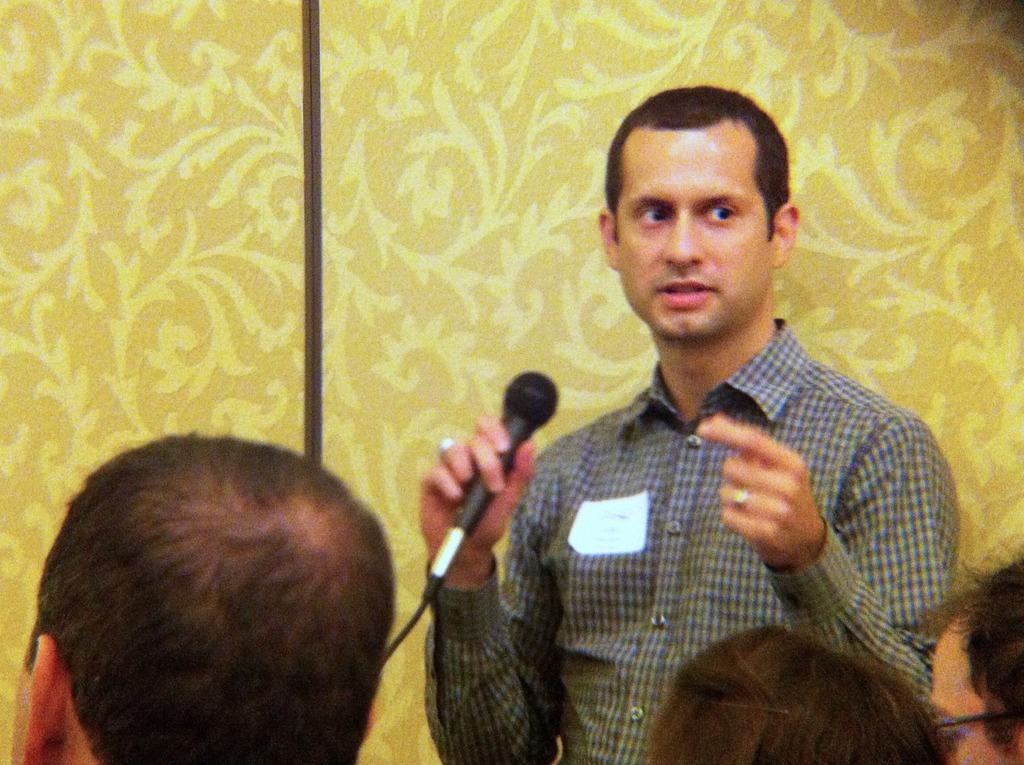Who is the main subject in the image? There is a man in the image. What is the man wearing? The man is wearing a checked shirt. What is the man holding in the image? The man is holding a mic. Can you describe the people sitting in front of the man? There are people sitting in front of the man, but their specific features are not mentioned in the facts. What color is the wall behind the man? The wall behind the man is yellow. What type of rabbit can be seen hopping on the yellow wall in the image? There is no rabbit present in the image, and the wall is not mentioned as being a surface for any animals to hop on. 